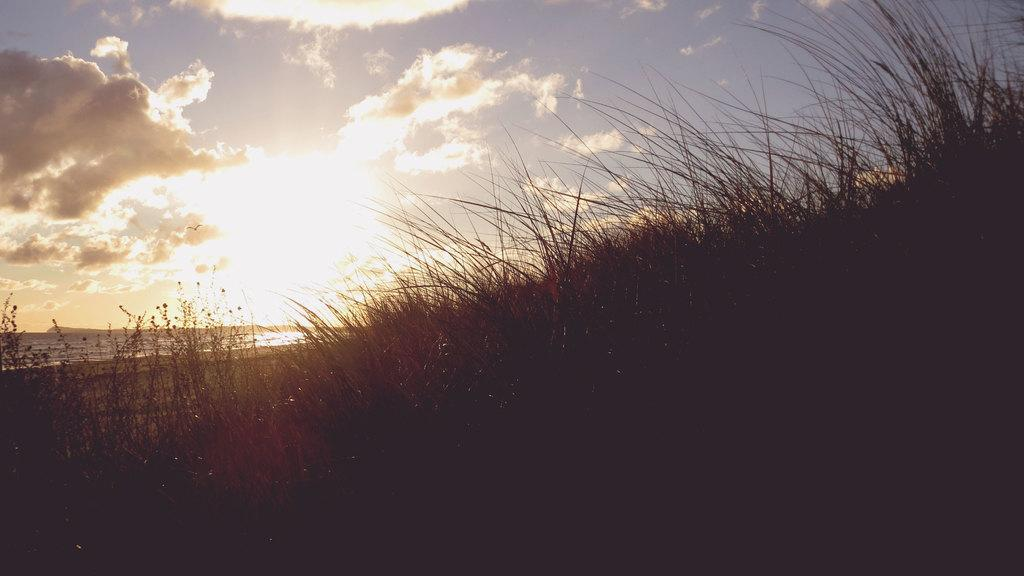What type of vegetation can be seen in the image? There is grass in the image. What else is visible besides the grass? There is water visible in the image. What can be seen in the background of the image? The sky is visible in the background of the image. What type of tooth is visible in the image? There is no tooth present in the image. Can you see any skateboarders in the image? There is no skateboarder or skate visible in the image. 